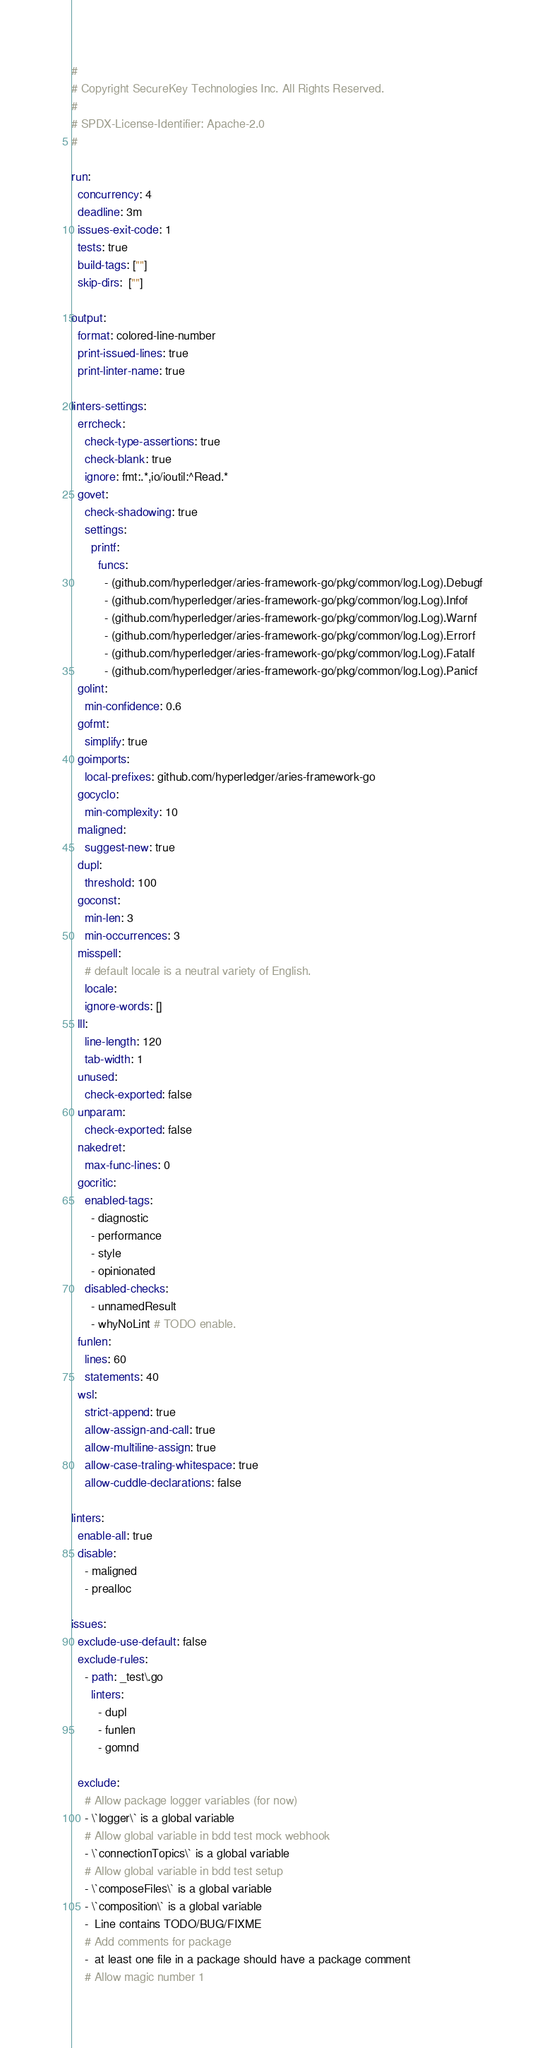Convert code to text. <code><loc_0><loc_0><loc_500><loc_500><_YAML_>#
# Copyright SecureKey Technologies Inc. All Rights Reserved.
#
# SPDX-License-Identifier: Apache-2.0
#

run:
  concurrency: 4
  deadline: 3m
  issues-exit-code: 1
  tests: true
  build-tags: [""]
  skip-dirs:  [""]

output:
  format: colored-line-number
  print-issued-lines: true
  print-linter-name: true

linters-settings:
  errcheck:
    check-type-assertions: true
    check-blank: true
    ignore: fmt:.*,io/ioutil:^Read.*
  govet:
    check-shadowing: true
    settings:
      printf:
        funcs:
          - (github.com/hyperledger/aries-framework-go/pkg/common/log.Log).Debugf
          - (github.com/hyperledger/aries-framework-go/pkg/common/log.Log).Infof
          - (github.com/hyperledger/aries-framework-go/pkg/common/log.Log).Warnf
          - (github.com/hyperledger/aries-framework-go/pkg/common/log.Log).Errorf
          - (github.com/hyperledger/aries-framework-go/pkg/common/log.Log).Fatalf
          - (github.com/hyperledger/aries-framework-go/pkg/common/log.Log).Panicf
  golint:
    min-confidence: 0.6
  gofmt:
    simplify: true
  goimports:
    local-prefixes: github.com/hyperledger/aries-framework-go
  gocyclo:
    min-complexity: 10
  maligned:
    suggest-new: true
  dupl:
    threshold: 100
  goconst:
    min-len: 3
    min-occurrences: 3
  misspell:
    # default locale is a neutral variety of English.
    locale:
    ignore-words: []
  lll:
    line-length: 120
    tab-width: 1
  unused:
    check-exported: false
  unparam:
    check-exported: false
  nakedret:
    max-func-lines: 0
  gocritic:
    enabled-tags:
      - diagnostic
      - performance
      - style
      - opinionated
    disabled-checks:
      - unnamedResult
      - whyNoLint # TODO enable.
  funlen:
    lines: 60
    statements: 40
  wsl:
    strict-append: true
    allow-assign-and-call: true
    allow-multiline-assign: true
    allow-case-traling-whitespace: true
    allow-cuddle-declarations: false

linters:
  enable-all: true
  disable:
    - maligned
    - prealloc

issues:
  exclude-use-default: false
  exclude-rules:
    - path: _test\.go
      linters:
        - dupl
        - funlen
        - gomnd

  exclude:
    # Allow package logger variables (for now)
    - \`logger\` is a global variable
    # Allow global variable in bdd test mock webhook
    - \`connectionTopics\` is a global variable
    # Allow global variable in bdd test setup
    - \`composeFiles\` is a global variable
    - \`composition\` is a global variable
    -  Line contains TODO/BUG/FIXME
    # Add comments for package
    -  at least one file in a package should have a package comment
    # Allow magic number 1</code> 